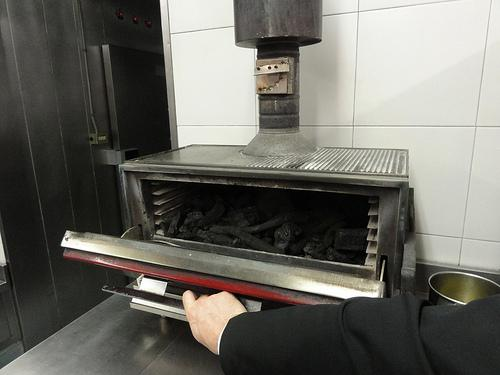Question: what is holding the oven door?
Choices:
A. Screw.
B. Stone.
C. A hand.
D. A white person's hand.
Answer with the letter. Answer: D Question: what is this thing being opened?
Choices:
A. Refrigerator.
B. An oven.
C. Bottle.
D. Can.
Answer with the letter. Answer: B Question: when will this hand disappear?
Choices:
A. When they hide it.
B. Someone got it.
C. When it moves.
D. After it's done with the stove.
Answer with the letter. Answer: D 